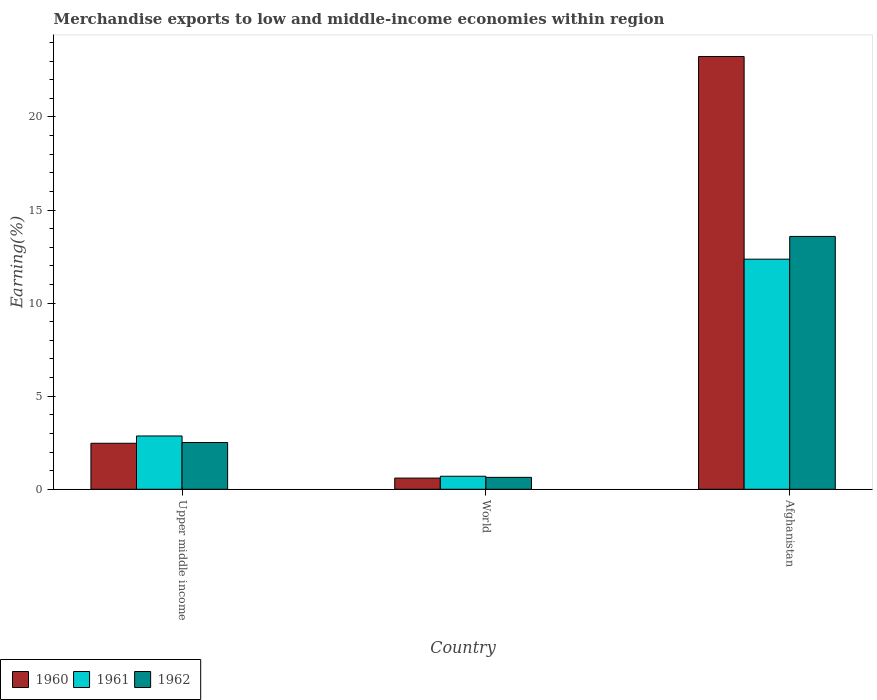Are the number of bars per tick equal to the number of legend labels?
Keep it short and to the point. Yes. Are the number of bars on each tick of the X-axis equal?
Your answer should be compact. Yes. How many bars are there on the 1st tick from the left?
Your response must be concise. 3. What is the percentage of amount earned from merchandise exports in 1960 in Afghanistan?
Keep it short and to the point. 23.25. Across all countries, what is the maximum percentage of amount earned from merchandise exports in 1961?
Make the answer very short. 12.36. Across all countries, what is the minimum percentage of amount earned from merchandise exports in 1962?
Give a very brief answer. 0.64. In which country was the percentage of amount earned from merchandise exports in 1962 maximum?
Your response must be concise. Afghanistan. In which country was the percentage of amount earned from merchandise exports in 1962 minimum?
Provide a succinct answer. World. What is the total percentage of amount earned from merchandise exports in 1961 in the graph?
Ensure brevity in your answer.  15.92. What is the difference between the percentage of amount earned from merchandise exports in 1961 in Afghanistan and that in World?
Provide a short and direct response. 11.66. What is the difference between the percentage of amount earned from merchandise exports in 1962 in Upper middle income and the percentage of amount earned from merchandise exports in 1961 in World?
Keep it short and to the point. 1.81. What is the average percentage of amount earned from merchandise exports in 1961 per country?
Offer a terse response. 5.31. What is the difference between the percentage of amount earned from merchandise exports of/in 1962 and percentage of amount earned from merchandise exports of/in 1961 in Afghanistan?
Offer a terse response. 1.22. What is the ratio of the percentage of amount earned from merchandise exports in 1960 in Upper middle income to that in World?
Your answer should be compact. 4.11. Is the percentage of amount earned from merchandise exports in 1961 in Afghanistan less than that in Upper middle income?
Provide a short and direct response. No. Is the difference between the percentage of amount earned from merchandise exports in 1962 in Upper middle income and World greater than the difference between the percentage of amount earned from merchandise exports in 1961 in Upper middle income and World?
Offer a very short reply. No. What is the difference between the highest and the second highest percentage of amount earned from merchandise exports in 1961?
Your answer should be compact. -2.16. What is the difference between the highest and the lowest percentage of amount earned from merchandise exports in 1961?
Keep it short and to the point. 11.66. Is the sum of the percentage of amount earned from merchandise exports in 1960 in Afghanistan and World greater than the maximum percentage of amount earned from merchandise exports in 1961 across all countries?
Offer a terse response. Yes. What does the 1st bar from the right in Upper middle income represents?
Give a very brief answer. 1962. How many countries are there in the graph?
Your response must be concise. 3. What is the difference between two consecutive major ticks on the Y-axis?
Your response must be concise. 5. Does the graph contain grids?
Your response must be concise. No. Where does the legend appear in the graph?
Keep it short and to the point. Bottom left. How are the legend labels stacked?
Provide a short and direct response. Horizontal. What is the title of the graph?
Ensure brevity in your answer.  Merchandise exports to low and middle-income economies within region. What is the label or title of the Y-axis?
Keep it short and to the point. Earning(%). What is the Earning(%) in 1960 in Upper middle income?
Give a very brief answer. 2.47. What is the Earning(%) of 1961 in Upper middle income?
Keep it short and to the point. 2.86. What is the Earning(%) of 1962 in Upper middle income?
Provide a succinct answer. 2.51. What is the Earning(%) in 1960 in World?
Keep it short and to the point. 0.6. What is the Earning(%) of 1961 in World?
Your response must be concise. 0.7. What is the Earning(%) in 1962 in World?
Offer a very short reply. 0.64. What is the Earning(%) of 1960 in Afghanistan?
Ensure brevity in your answer.  23.25. What is the Earning(%) of 1961 in Afghanistan?
Ensure brevity in your answer.  12.36. What is the Earning(%) of 1962 in Afghanistan?
Offer a terse response. 13.58. Across all countries, what is the maximum Earning(%) of 1960?
Keep it short and to the point. 23.25. Across all countries, what is the maximum Earning(%) of 1961?
Your response must be concise. 12.36. Across all countries, what is the maximum Earning(%) of 1962?
Give a very brief answer. 13.58. Across all countries, what is the minimum Earning(%) in 1960?
Make the answer very short. 0.6. Across all countries, what is the minimum Earning(%) in 1961?
Your answer should be very brief. 0.7. Across all countries, what is the minimum Earning(%) of 1962?
Your response must be concise. 0.64. What is the total Earning(%) in 1960 in the graph?
Provide a succinct answer. 26.32. What is the total Earning(%) in 1961 in the graph?
Give a very brief answer. 15.92. What is the total Earning(%) of 1962 in the graph?
Offer a terse response. 16.73. What is the difference between the Earning(%) of 1960 in Upper middle income and that in World?
Make the answer very short. 1.87. What is the difference between the Earning(%) in 1961 in Upper middle income and that in World?
Your response must be concise. 2.16. What is the difference between the Earning(%) in 1962 in Upper middle income and that in World?
Your response must be concise. 1.87. What is the difference between the Earning(%) in 1960 in Upper middle income and that in Afghanistan?
Your answer should be very brief. -20.78. What is the difference between the Earning(%) in 1961 in Upper middle income and that in Afghanistan?
Provide a short and direct response. -9.5. What is the difference between the Earning(%) of 1962 in Upper middle income and that in Afghanistan?
Offer a terse response. -11.07. What is the difference between the Earning(%) of 1960 in World and that in Afghanistan?
Your answer should be compact. -22.65. What is the difference between the Earning(%) in 1961 in World and that in Afghanistan?
Offer a very short reply. -11.66. What is the difference between the Earning(%) in 1962 in World and that in Afghanistan?
Your response must be concise. -12.94. What is the difference between the Earning(%) of 1960 in Upper middle income and the Earning(%) of 1961 in World?
Keep it short and to the point. 1.77. What is the difference between the Earning(%) in 1960 in Upper middle income and the Earning(%) in 1962 in World?
Your response must be concise. 1.83. What is the difference between the Earning(%) of 1961 in Upper middle income and the Earning(%) of 1962 in World?
Your answer should be compact. 2.22. What is the difference between the Earning(%) in 1960 in Upper middle income and the Earning(%) in 1961 in Afghanistan?
Offer a terse response. -9.89. What is the difference between the Earning(%) of 1960 in Upper middle income and the Earning(%) of 1962 in Afghanistan?
Your answer should be very brief. -11.11. What is the difference between the Earning(%) of 1961 in Upper middle income and the Earning(%) of 1962 in Afghanistan?
Give a very brief answer. -10.72. What is the difference between the Earning(%) in 1960 in World and the Earning(%) in 1961 in Afghanistan?
Make the answer very short. -11.76. What is the difference between the Earning(%) of 1960 in World and the Earning(%) of 1962 in Afghanistan?
Make the answer very short. -12.98. What is the difference between the Earning(%) of 1961 in World and the Earning(%) of 1962 in Afghanistan?
Provide a short and direct response. -12.88. What is the average Earning(%) in 1960 per country?
Offer a very short reply. 8.77. What is the average Earning(%) of 1961 per country?
Your answer should be very brief. 5.31. What is the average Earning(%) in 1962 per country?
Offer a very short reply. 5.58. What is the difference between the Earning(%) of 1960 and Earning(%) of 1961 in Upper middle income?
Give a very brief answer. -0.39. What is the difference between the Earning(%) in 1960 and Earning(%) in 1962 in Upper middle income?
Provide a succinct answer. -0.04. What is the difference between the Earning(%) in 1961 and Earning(%) in 1962 in Upper middle income?
Your response must be concise. 0.35. What is the difference between the Earning(%) in 1960 and Earning(%) in 1961 in World?
Make the answer very short. -0.1. What is the difference between the Earning(%) of 1960 and Earning(%) of 1962 in World?
Provide a short and direct response. -0.04. What is the difference between the Earning(%) of 1961 and Earning(%) of 1962 in World?
Offer a very short reply. 0.06. What is the difference between the Earning(%) of 1960 and Earning(%) of 1961 in Afghanistan?
Make the answer very short. 10.89. What is the difference between the Earning(%) in 1960 and Earning(%) in 1962 in Afghanistan?
Provide a succinct answer. 9.66. What is the difference between the Earning(%) of 1961 and Earning(%) of 1962 in Afghanistan?
Offer a terse response. -1.22. What is the ratio of the Earning(%) of 1960 in Upper middle income to that in World?
Keep it short and to the point. 4.11. What is the ratio of the Earning(%) of 1961 in Upper middle income to that in World?
Your answer should be compact. 4.09. What is the ratio of the Earning(%) in 1962 in Upper middle income to that in World?
Ensure brevity in your answer.  3.92. What is the ratio of the Earning(%) of 1960 in Upper middle income to that in Afghanistan?
Offer a terse response. 0.11. What is the ratio of the Earning(%) of 1961 in Upper middle income to that in Afghanistan?
Offer a terse response. 0.23. What is the ratio of the Earning(%) in 1962 in Upper middle income to that in Afghanistan?
Make the answer very short. 0.18. What is the ratio of the Earning(%) of 1960 in World to that in Afghanistan?
Provide a succinct answer. 0.03. What is the ratio of the Earning(%) of 1961 in World to that in Afghanistan?
Ensure brevity in your answer.  0.06. What is the ratio of the Earning(%) in 1962 in World to that in Afghanistan?
Provide a short and direct response. 0.05. What is the difference between the highest and the second highest Earning(%) in 1960?
Your answer should be very brief. 20.78. What is the difference between the highest and the second highest Earning(%) of 1961?
Give a very brief answer. 9.5. What is the difference between the highest and the second highest Earning(%) in 1962?
Ensure brevity in your answer.  11.07. What is the difference between the highest and the lowest Earning(%) in 1960?
Keep it short and to the point. 22.65. What is the difference between the highest and the lowest Earning(%) of 1961?
Give a very brief answer. 11.66. What is the difference between the highest and the lowest Earning(%) in 1962?
Ensure brevity in your answer.  12.94. 